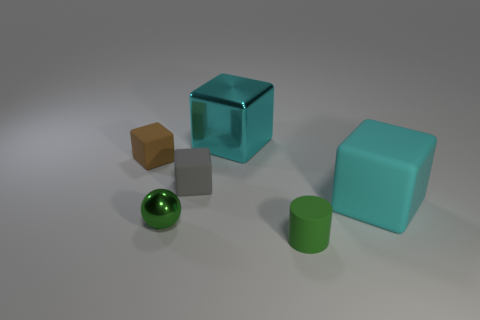What number of other objects are the same material as the sphere?
Give a very brief answer. 1. There is a matte block on the left side of the gray object; what is its color?
Ensure brevity in your answer.  Brown. What material is the cube that is right of the cyan cube that is behind the tiny thing behind the gray matte cube?
Your answer should be very brief. Rubber. Is there a tiny rubber object that has the same shape as the large rubber thing?
Your answer should be compact. Yes. What shape is the green rubber thing that is the same size as the brown block?
Your answer should be very brief. Cylinder. What number of small matte things are on the left side of the big cyan metallic object and in front of the tiny brown matte cube?
Your answer should be very brief. 1. Is the number of big cyan cubes behind the large metal thing less than the number of green shiny blocks?
Offer a terse response. No. Are there any red objects that have the same size as the cyan rubber thing?
Offer a terse response. No. What is the color of the thing that is the same material as the tiny green sphere?
Offer a very short reply. Cyan. There is a large cyan thing that is right of the green cylinder; what number of balls are behind it?
Your response must be concise. 0. 